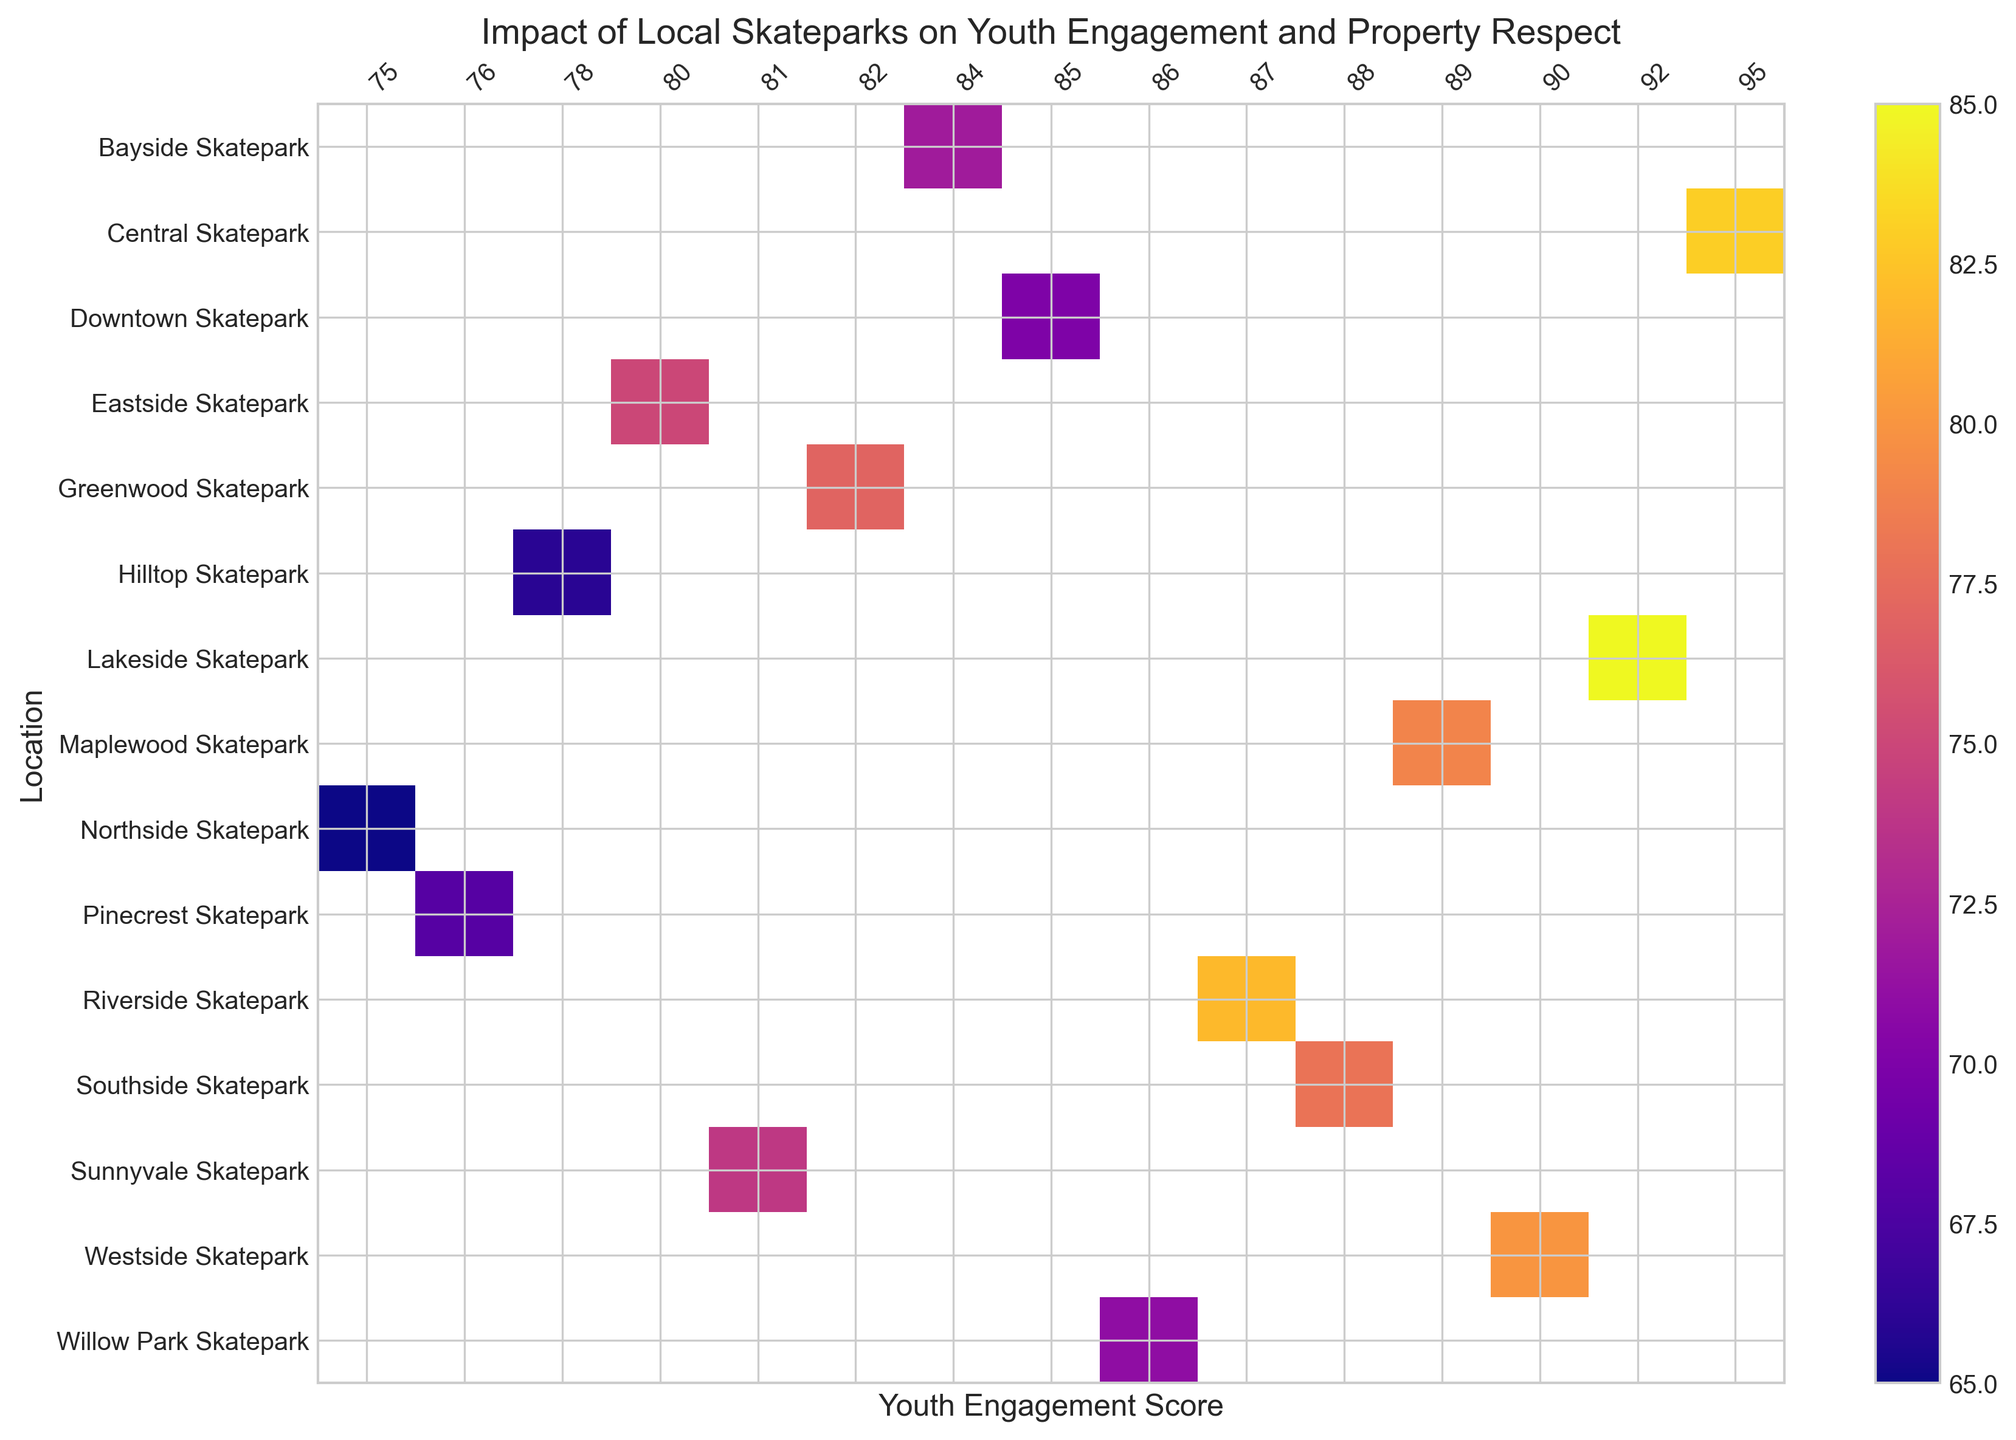Which skatepark has the highest Property Respect Score? Observe the heatmap and locate the maximum value on the Property Respect Score axis.
Answer: Lakeside Skatepark Which skatepark shows the lowest Youth Engagement Score? Look for the minimum value on the Youth Engagement Score axis.
Answer: Northside Skatepark Which two skateparks have the same Property Respect Score and what is it? Identify any two locations on the heatmap that share the same color shade and Property Respect Score value. Check labels to confirm.
Answer: Eastside Skatepark and Greenwood Skatepark, 77 Is there a positive correlation between Youth Engagement Score and Property Respect Score across skateparks? Examine the overall trend in the heatmap to assess if higher Youth Engagement Scores tend to be associated with higher Property Respect Scores.
Answer: Yes 